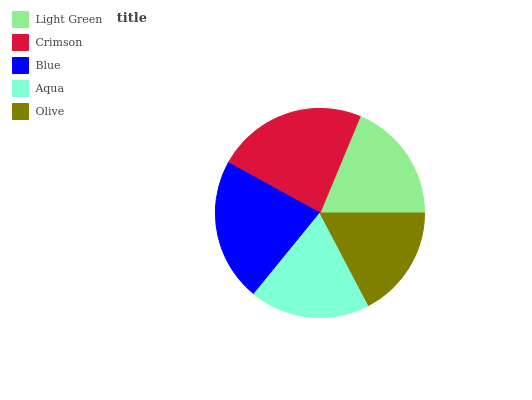Is Olive the minimum?
Answer yes or no. Yes. Is Crimson the maximum?
Answer yes or no. Yes. Is Blue the minimum?
Answer yes or no. No. Is Blue the maximum?
Answer yes or no. No. Is Crimson greater than Blue?
Answer yes or no. Yes. Is Blue less than Crimson?
Answer yes or no. Yes. Is Blue greater than Crimson?
Answer yes or no. No. Is Crimson less than Blue?
Answer yes or no. No. Is Light Green the high median?
Answer yes or no. Yes. Is Light Green the low median?
Answer yes or no. Yes. Is Crimson the high median?
Answer yes or no. No. Is Blue the low median?
Answer yes or no. No. 